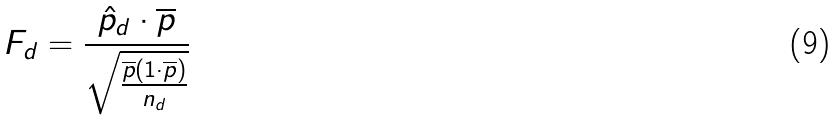<formula> <loc_0><loc_0><loc_500><loc_500>F _ { d } = \frac { \hat { p } _ { d } \cdot \overline { p } } { \sqrt { \frac { \overline { p } ( 1 \cdot \overline { p } ) } { n _ { d } } } }</formula> 